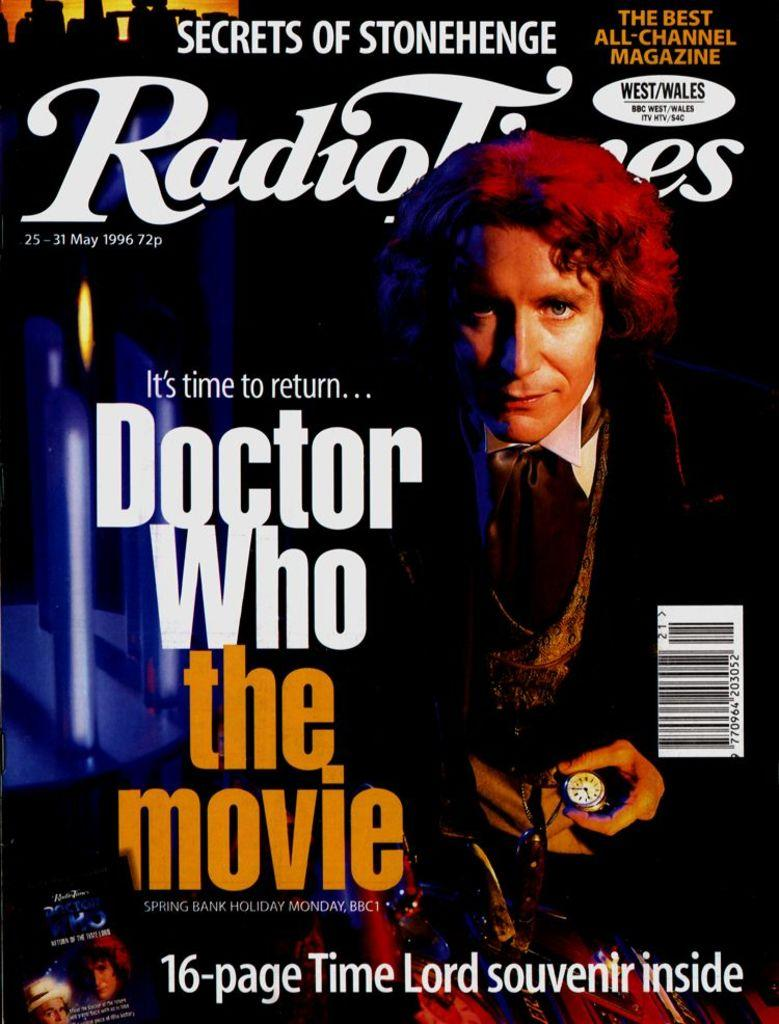<image>
Write a terse but informative summary of the picture. A magazine advertises the Doctor Who movie and a souvenir inside. 